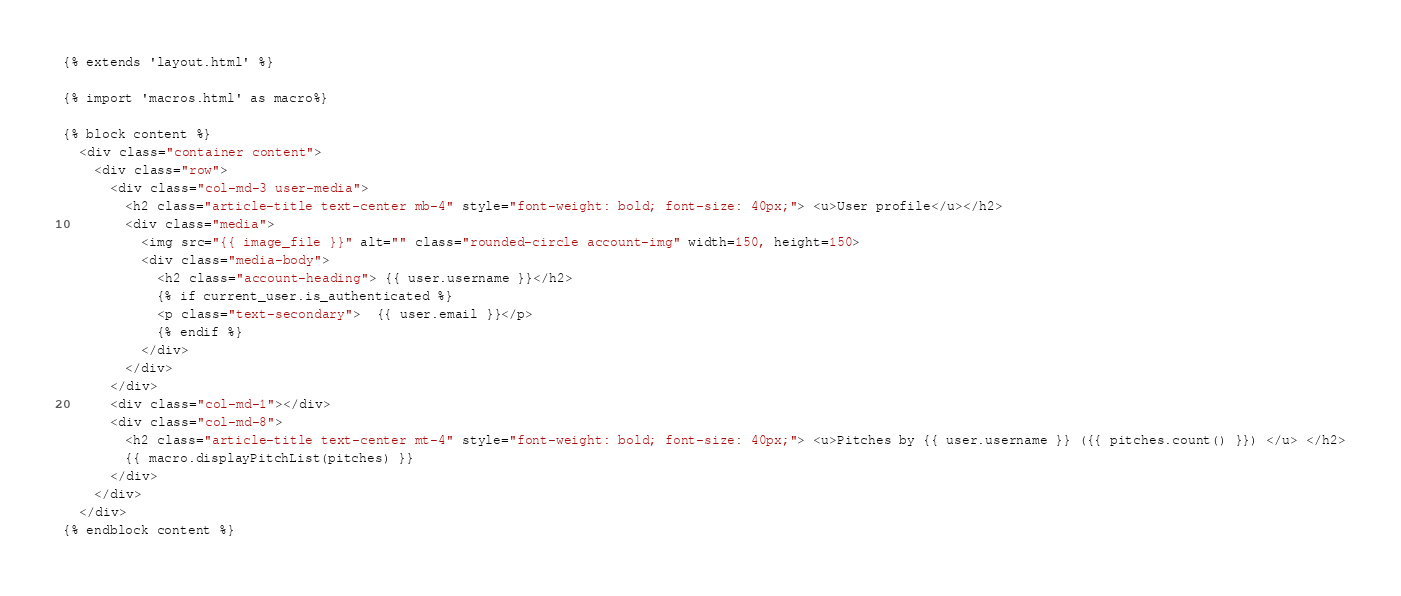<code> <loc_0><loc_0><loc_500><loc_500><_HTML_>{% extends 'layout.html' %}

{% import 'macros.html' as macro%}

{% block content %}
  <div class="container content">
    <div class="row">
      <div class="col-md-3 user-media">
        <h2 class="article-title text-center mb-4" style="font-weight: bold; font-size: 40px;"> <u>User profile</u></h2>
        <div class="media">
          <img src="{{ image_file }}" alt="" class="rounded-circle account-img" width=150, height=150>
          <div class="media-body">
            <h2 class="account-heading"> {{ user.username }}</h2>
            {% if current_user.is_authenticated %}
            <p class="text-secondary">  {{ user.email }}</p>
            {% endif %}
          </div>
        </div>   
      </div>
      <div class="col-md-1"></div>
      <div class="col-md-8">
        <h2 class="article-title text-center mt-4" style="font-weight: bold; font-size: 40px;"> <u>Pitches by {{ user.username }} ({{ pitches.count() }}) </u> </h2>
        {{ macro.displayPitchList(pitches) }}
      </div>
    </div>
  </div>
{% endblock content %}
</code> 